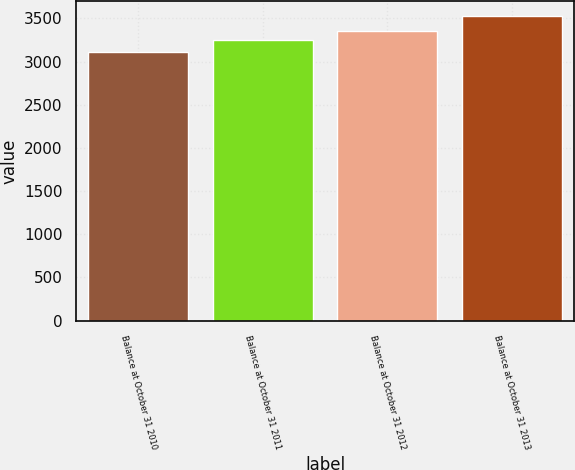Convert chart to OTSL. <chart><loc_0><loc_0><loc_500><loc_500><bar_chart><fcel>Balance at October 31 2010<fcel>Balance at October 31 2011<fcel>Balance at October 31 2012<fcel>Balance at October 31 2013<nl><fcel>3106<fcel>3252<fcel>3352<fcel>3524<nl></chart> 